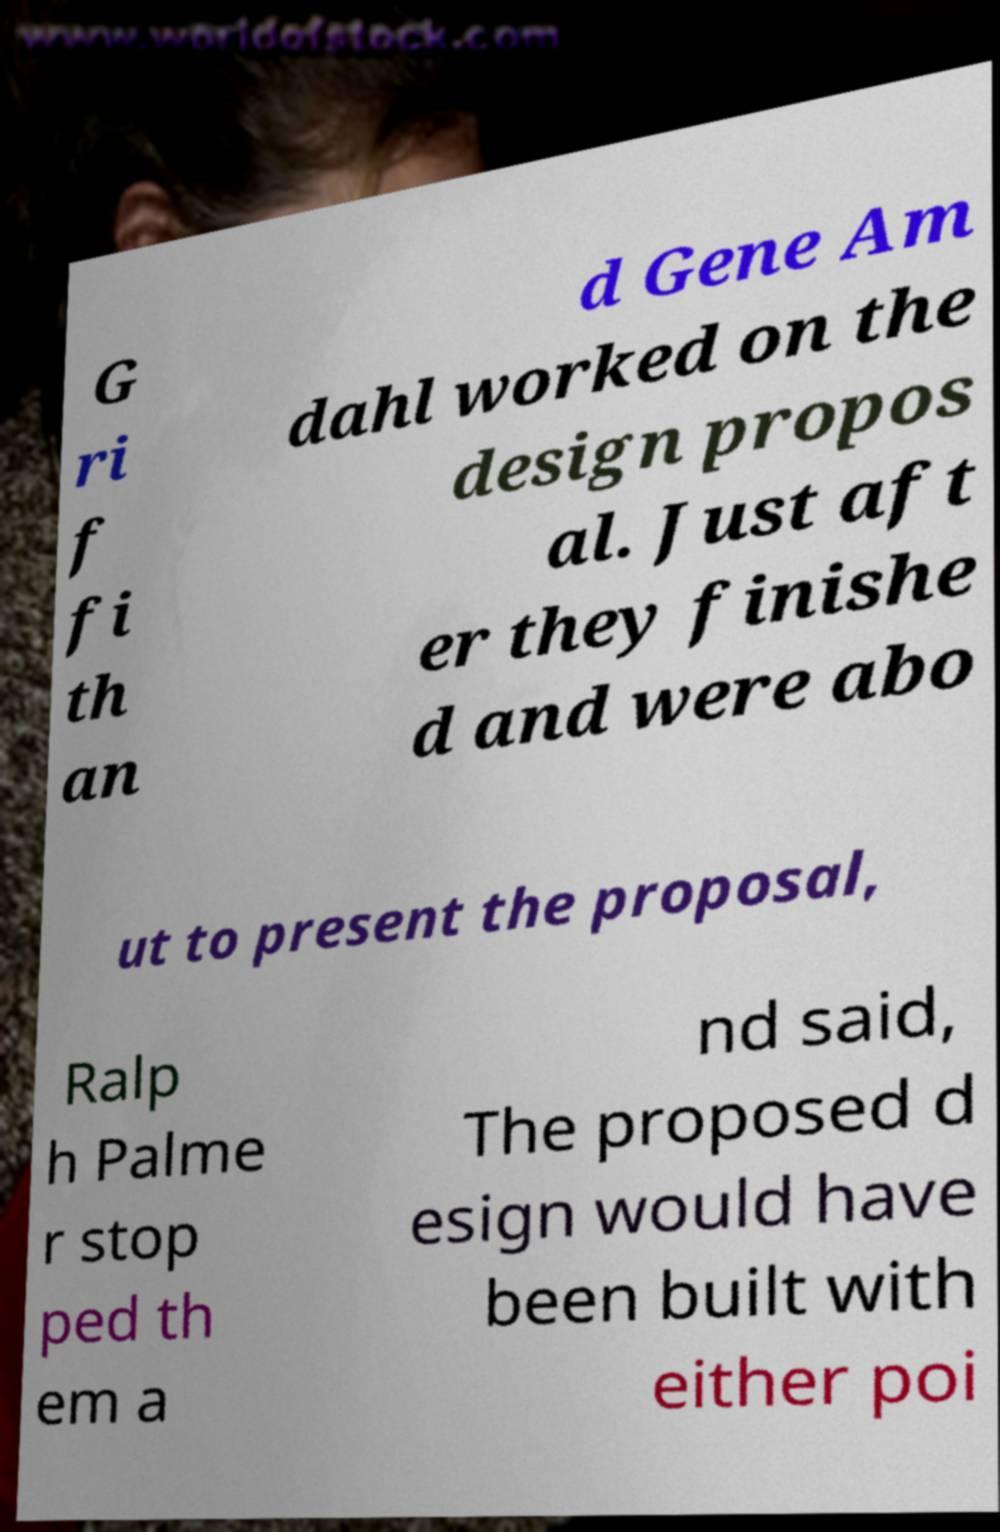What messages or text are displayed in this image? I need them in a readable, typed format. G ri f fi th an d Gene Am dahl worked on the design propos al. Just aft er they finishe d and were abo ut to present the proposal, Ralp h Palme r stop ped th em a nd said, The proposed d esign would have been built with either poi 